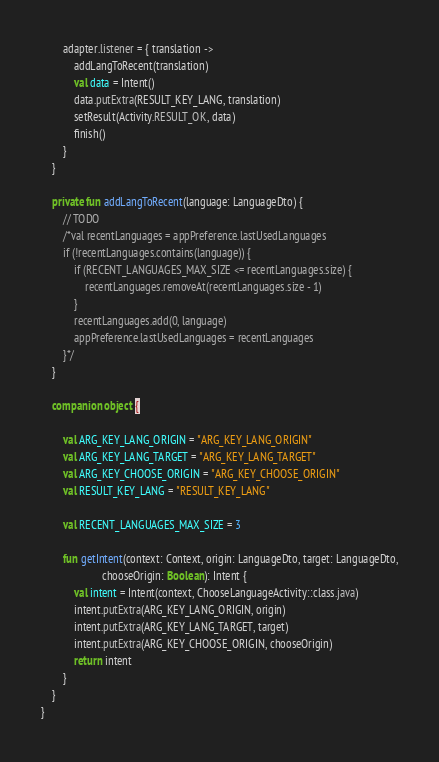<code> <loc_0><loc_0><loc_500><loc_500><_Kotlin_>
        adapter.listener = { translation ->
            addLangToRecent(translation)
            val data = Intent()
            data.putExtra(RESULT_KEY_LANG, translation)
            setResult(Activity.RESULT_OK, data)
            finish()
        }
    }

    private fun addLangToRecent(language: LanguageDto) {
        // TODO
        /*val recentLanguages = appPreference.lastUsedLanguages
        if (!recentLanguages.contains(language)) {
            if (RECENT_LANGUAGES_MAX_SIZE <= recentLanguages.size) {
                recentLanguages.removeAt(recentLanguages.size - 1)
            }
            recentLanguages.add(0, language)
            appPreference.lastUsedLanguages = recentLanguages
        }*/
    }

    companion object {

        val ARG_KEY_LANG_ORIGIN = "ARG_KEY_LANG_ORIGIN"
        val ARG_KEY_LANG_TARGET = "ARG_KEY_LANG_TARGET"
        val ARG_KEY_CHOOSE_ORIGIN = "ARG_KEY_CHOOSE_ORIGIN"
        val RESULT_KEY_LANG = "RESULT_KEY_LANG"

        val RECENT_LANGUAGES_MAX_SIZE = 3

        fun getIntent(context: Context, origin: LanguageDto, target: LanguageDto,
                      chooseOrigin: Boolean): Intent {
            val intent = Intent(context, ChooseLanguageActivity::class.java)
            intent.putExtra(ARG_KEY_LANG_ORIGIN, origin)
            intent.putExtra(ARG_KEY_LANG_TARGET, target)
            intent.putExtra(ARG_KEY_CHOOSE_ORIGIN, chooseOrigin)
            return intent
        }
    }
}
</code> 